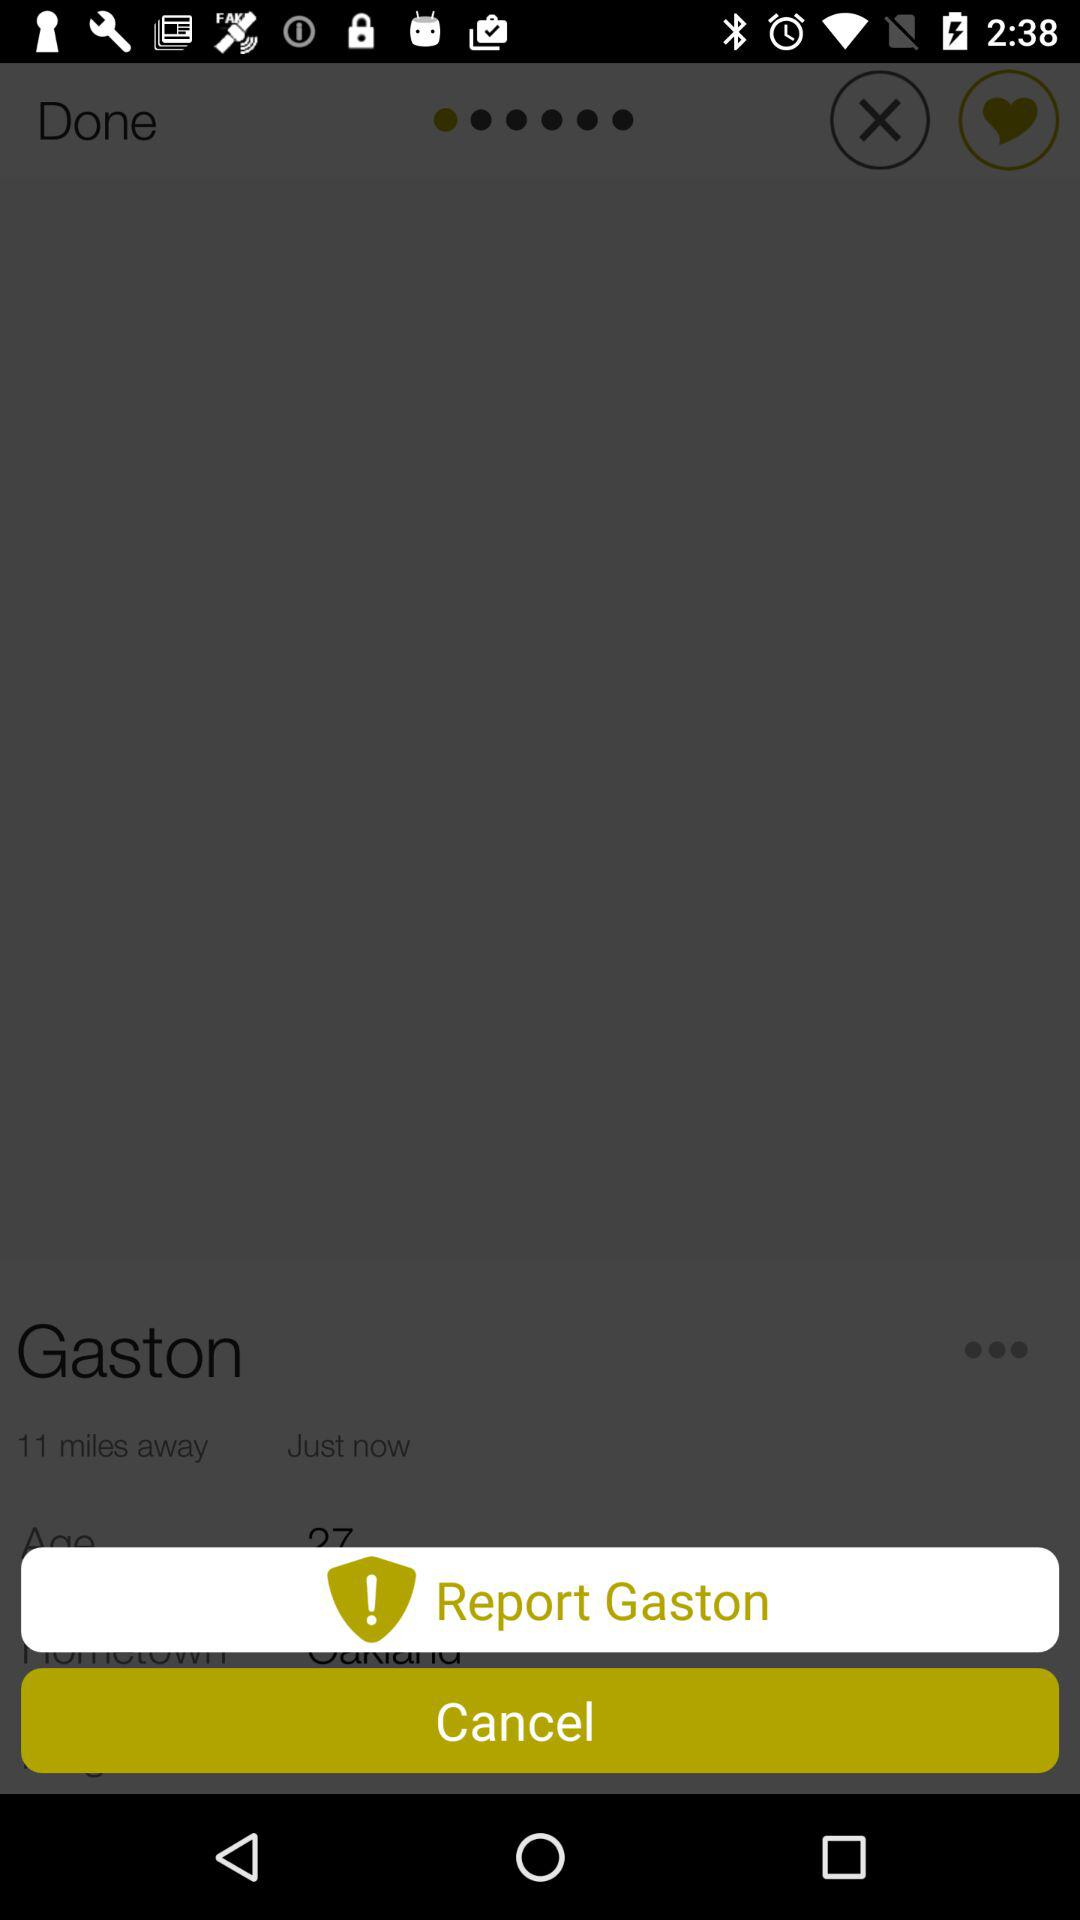How many years old is Gaston?
Answer the question using a single word or phrase. 27 